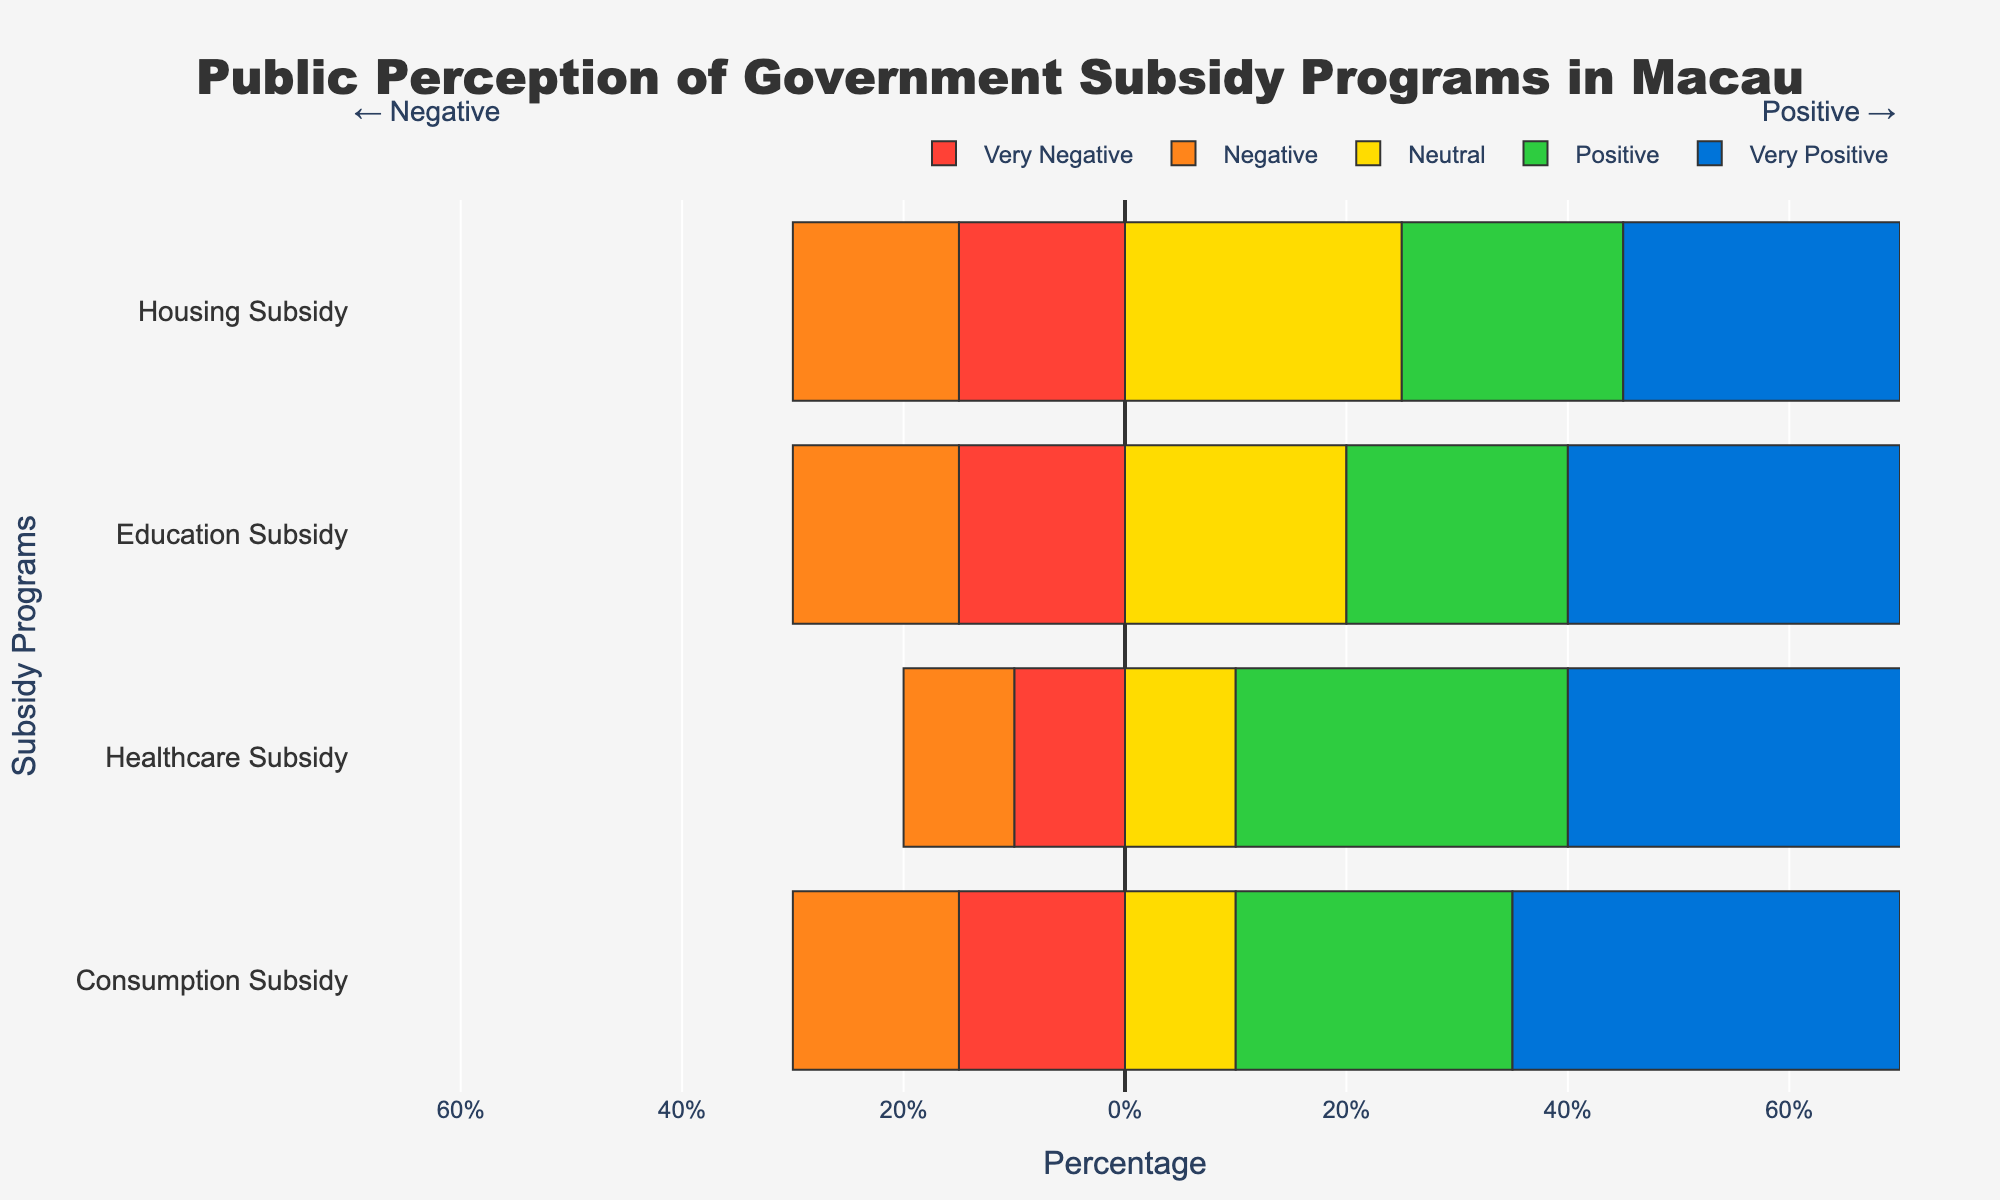Which subsidy program has the highest percentage of very positive sentiment? The healthcare subsidy has the highest percentage of very positive sentiment at 40%, which can be observed directly from the bar chart where its bar extends farthest to the right in the very positive category.
Answer: Healthcare Subsidy How does the percentage of negative sentiment for Education Subsidy compare to that for Housing Subsidy? The negative sentiment for both Education Subsidy and Housing Subsidy is the same, as both have 15% in the negative sentiment category. This can be seen by comparing the lengths of the bars extending to the left of the 0% line.
Answer: Equal Which subsidy program has the highest combined percentage of positive and very positive sentiments? By adding the positive and very positive percentages for each program: Consumption Subsidy (25% + 35% = 60%), Healthcare Subsidy (30% + 40% = 70%), Education Subsidy (20% + 30% = 50%), and Housing Subsidy (20% + 25% = 45%), it can be determined that Healthcare Subsidy has the highest combined percentage.
Answer: Healthcare Subsidy What percentage of respondents have either a neutral or positive sentiment towards the Education Subsidy? The percentages for neutral and positive sentiments for Education Subsidy are 20% and 20% respectively. Adding these values together gives: 20% + 20% = 40%.
Answer: 40% What is the difference in the percentage of very negative sentiment between Consumption Subsidy and Healthcare Subsidy? The percentage of very negative sentiment for Consumption Subsidy is 15%, while for Healthcare Subsidy it is 10%. The difference is calculated as 15% - 10% = 5%.
Answer: 5% If we compare the total negative sentiments (negative + very negative), which program has the lowest percentage? Summing the negative and very negative sentiments for each program: Consumption Subsidy (15% + 15% = 30%), Healthcare Subsidy (10% + 10% = 20%), Education Subsidy (15% + 15% = 30%), and Housing Subsidy (15% + 15% = 30%), we find that Healthcare Subsidy has the lowest total negative sentiments at 20%.
Answer: Healthcare Subsidy Which subsidy program has the most balanced sentiment distribution, i.e., the highest percentage for the neutral category? Observing the neutral category bars, Housing Subsidy has the highest percentage at 25%, indicating a more balanced distribution of sentiment than the other programs.
Answer: Housing Subsidy 